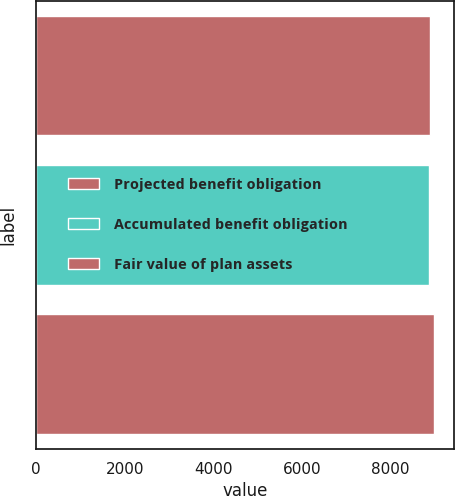Convert chart to OTSL. <chart><loc_0><loc_0><loc_500><loc_500><bar_chart><fcel>Projected benefit obligation<fcel>Accumulated benefit obligation<fcel>Fair value of plan assets<nl><fcel>8880<fcel>8861<fcel>8980<nl></chart> 